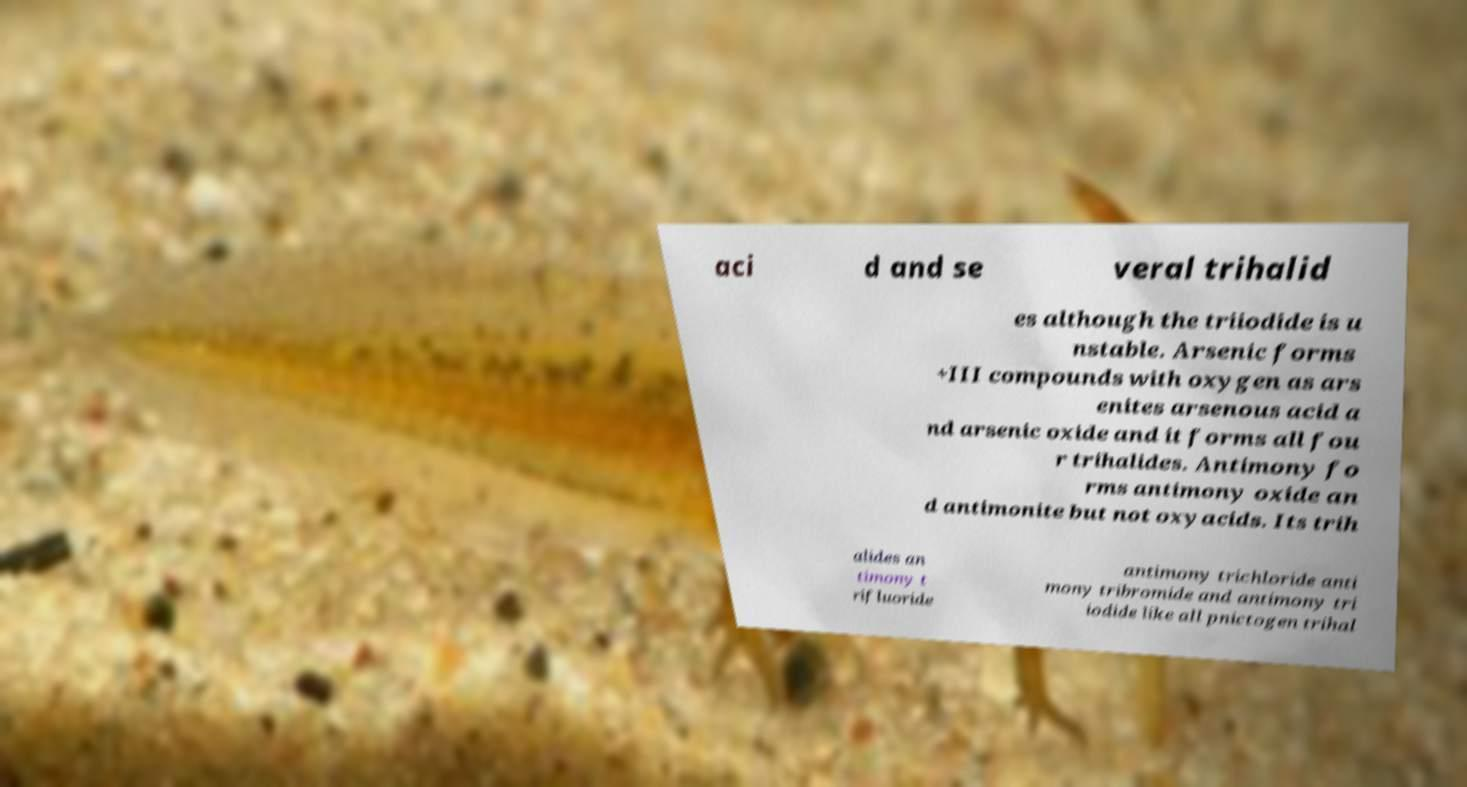Could you extract and type out the text from this image? aci d and se veral trihalid es although the triiodide is u nstable. Arsenic forms +III compounds with oxygen as ars enites arsenous acid a nd arsenic oxide and it forms all fou r trihalides. Antimony fo rms antimony oxide an d antimonite but not oxyacids. Its trih alides an timony t rifluoride antimony trichloride anti mony tribromide and antimony tri iodide like all pnictogen trihal 